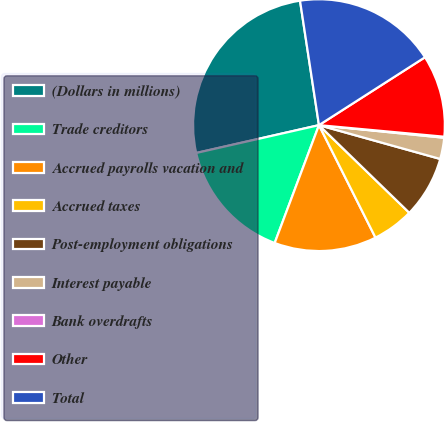Convert chart. <chart><loc_0><loc_0><loc_500><loc_500><pie_chart><fcel>(Dollars in millions)<fcel>Trade creditors<fcel>Accrued payrolls vacation and<fcel>Accrued taxes<fcel>Post-employment obligations<fcel>Interest payable<fcel>Bank overdrafts<fcel>Other<fcel>Total<nl><fcel>26.14%<fcel>15.73%<fcel>13.13%<fcel>5.33%<fcel>7.93%<fcel>2.73%<fcel>0.13%<fcel>10.53%<fcel>18.34%<nl></chart> 